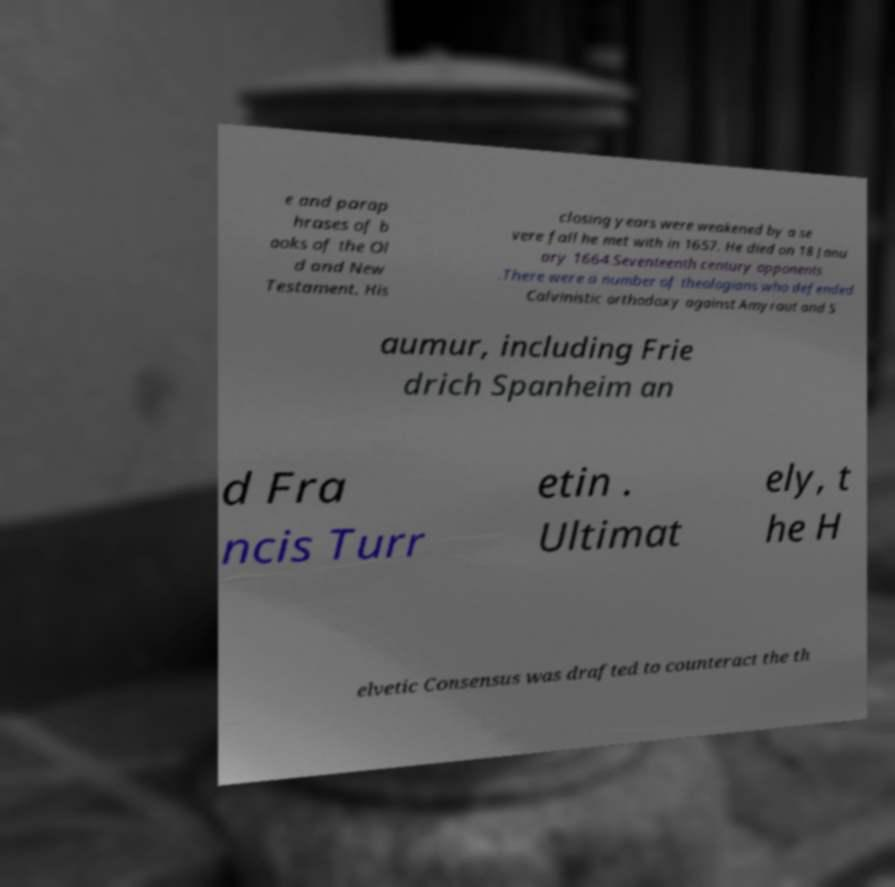Can you accurately transcribe the text from the provided image for me? e and parap hrases of b ooks of the Ol d and New Testament. His closing years were weakened by a se vere fall he met with in 1657. He died on 18 Janu ary 1664.Seventeenth century opponents .There were a number of theologians who defended Calvinistic orthodoxy against Amyraut and S aumur, including Frie drich Spanheim an d Fra ncis Turr etin . Ultimat ely, t he H elvetic Consensus was drafted to counteract the th 